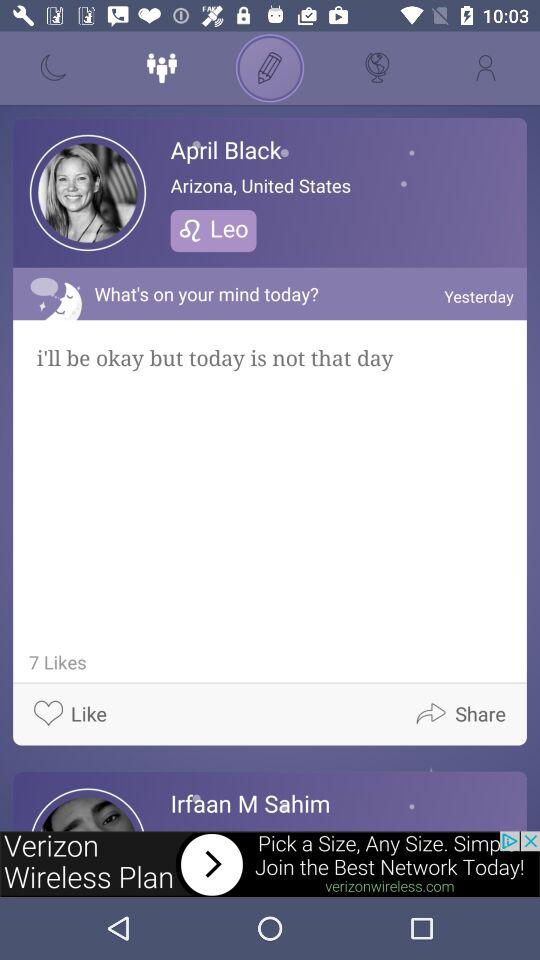How many more likes does the post have than comments?
Answer the question using a single word or phrase. 7 